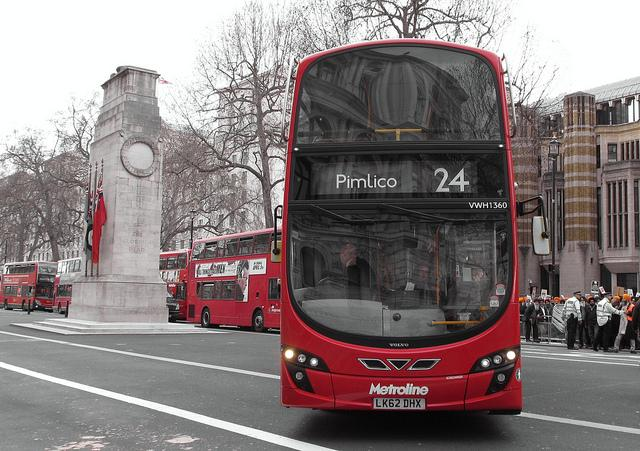Which bus company owns this bus?

Choices:
A) metroline
B) pimlico
C) vwh
D) volvo metroline 